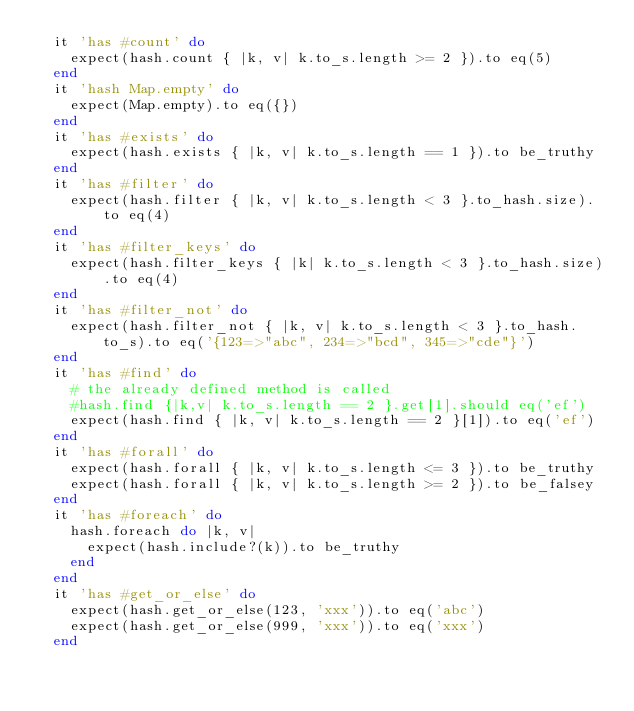Convert code to text. <code><loc_0><loc_0><loc_500><loc_500><_Ruby_>  it 'has #count' do
    expect(hash.count { |k, v| k.to_s.length >= 2 }).to eq(5)
  end
  it 'hash Map.empty' do
    expect(Map.empty).to eq({})
  end
  it 'has #exists' do
    expect(hash.exists { |k, v| k.to_s.length == 1 }).to be_truthy
  end
  it 'has #filter' do
    expect(hash.filter { |k, v| k.to_s.length < 3 }.to_hash.size).to eq(4)
  end
  it 'has #filter_keys' do
    expect(hash.filter_keys { |k| k.to_s.length < 3 }.to_hash.size).to eq(4)
  end
  it 'has #filter_not' do
    expect(hash.filter_not { |k, v| k.to_s.length < 3 }.to_hash.to_s).to eq('{123=>"abc", 234=>"bcd", 345=>"cde"}')
  end
  it 'has #find' do
    # the already defined method is called
    #hash.find {|k,v| k.to_s.length == 2 }.get[1].should eq('ef')
    expect(hash.find { |k, v| k.to_s.length == 2 }[1]).to eq('ef')
  end
  it 'has #forall' do
    expect(hash.forall { |k, v| k.to_s.length <= 3 }).to be_truthy
    expect(hash.forall { |k, v| k.to_s.length >= 2 }).to be_falsey
  end
  it 'has #foreach' do
    hash.foreach do |k, v|
      expect(hash.include?(k)).to be_truthy
    end
  end
  it 'has #get_or_else' do
    expect(hash.get_or_else(123, 'xxx')).to eq('abc')
    expect(hash.get_or_else(999, 'xxx')).to eq('xxx')
  end</code> 